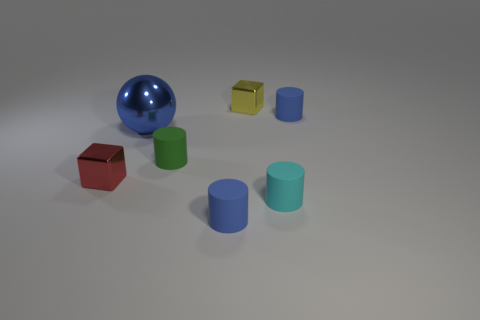Subtract all small cyan cylinders. How many cylinders are left? 3 Add 3 large blue metal things. How many objects exist? 10 Subtract all cyan cylinders. How many cylinders are left? 3 Subtract all balls. How many objects are left? 6 Subtract 1 cylinders. How many cylinders are left? 3 Subtract all purple balls. Subtract all purple cylinders. How many balls are left? 1 Subtract all yellow cylinders. How many green balls are left? 0 Subtract all tiny brown metallic cylinders. Subtract all small yellow objects. How many objects are left? 6 Add 5 tiny yellow blocks. How many tiny yellow blocks are left? 6 Add 2 blue rubber cylinders. How many blue rubber cylinders exist? 4 